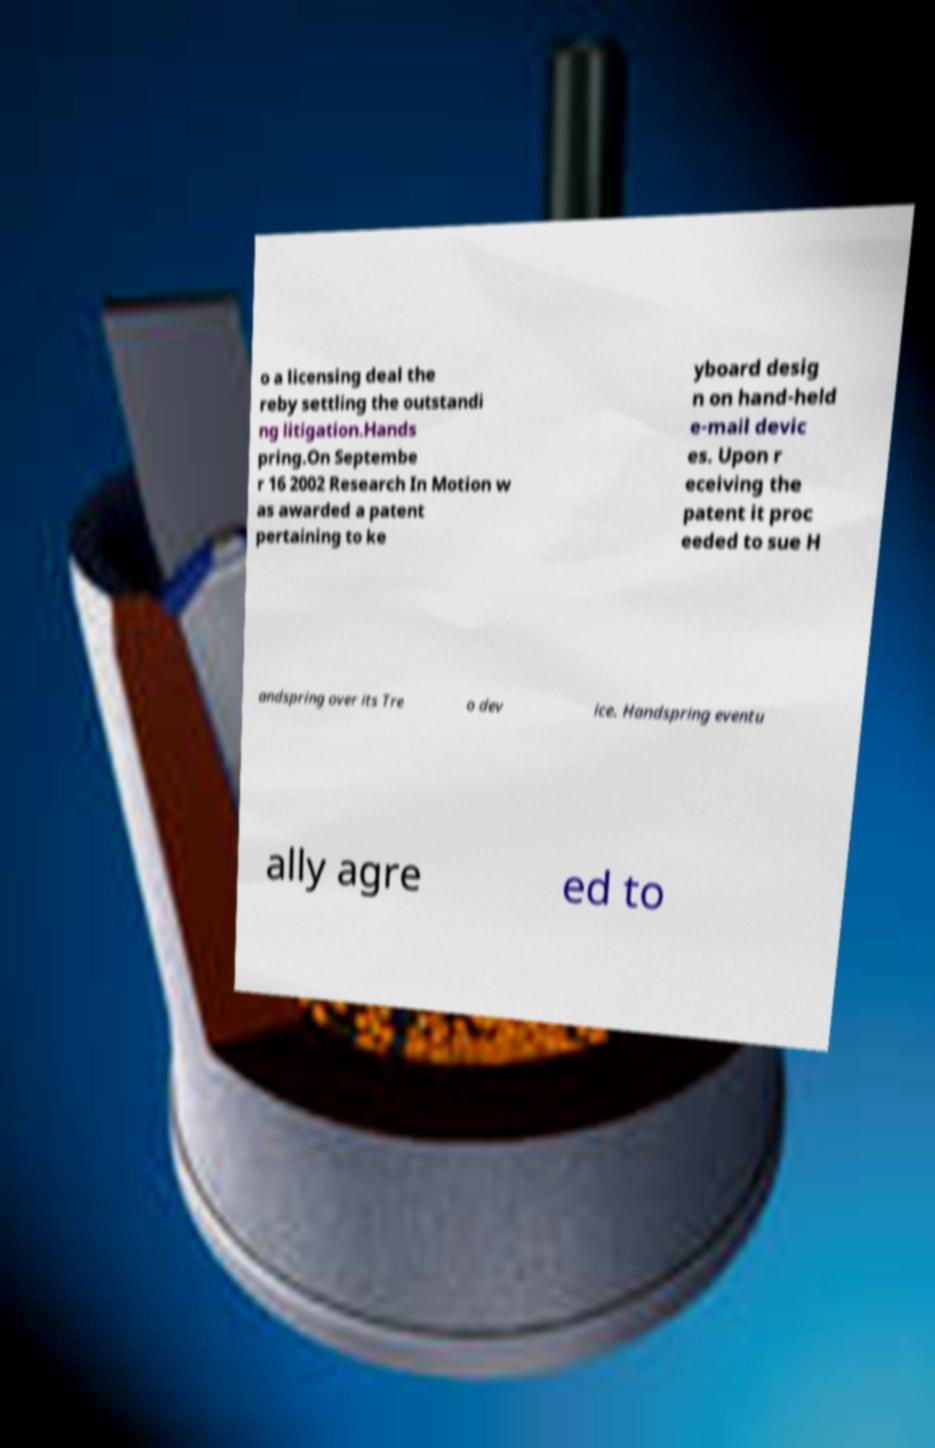There's text embedded in this image that I need extracted. Can you transcribe it verbatim? o a licensing deal the reby settling the outstandi ng litigation.Hands pring.On Septembe r 16 2002 Research In Motion w as awarded a patent pertaining to ke yboard desig n on hand-held e-mail devic es. Upon r eceiving the patent it proc eeded to sue H andspring over its Tre o dev ice. Handspring eventu ally agre ed to 